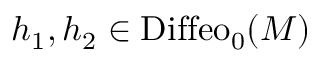Convert formula to latex. <formula><loc_0><loc_0><loc_500><loc_500>h _ { 1 } , h _ { 2 } \in D i f f e o _ { 0 } ( M )</formula> 